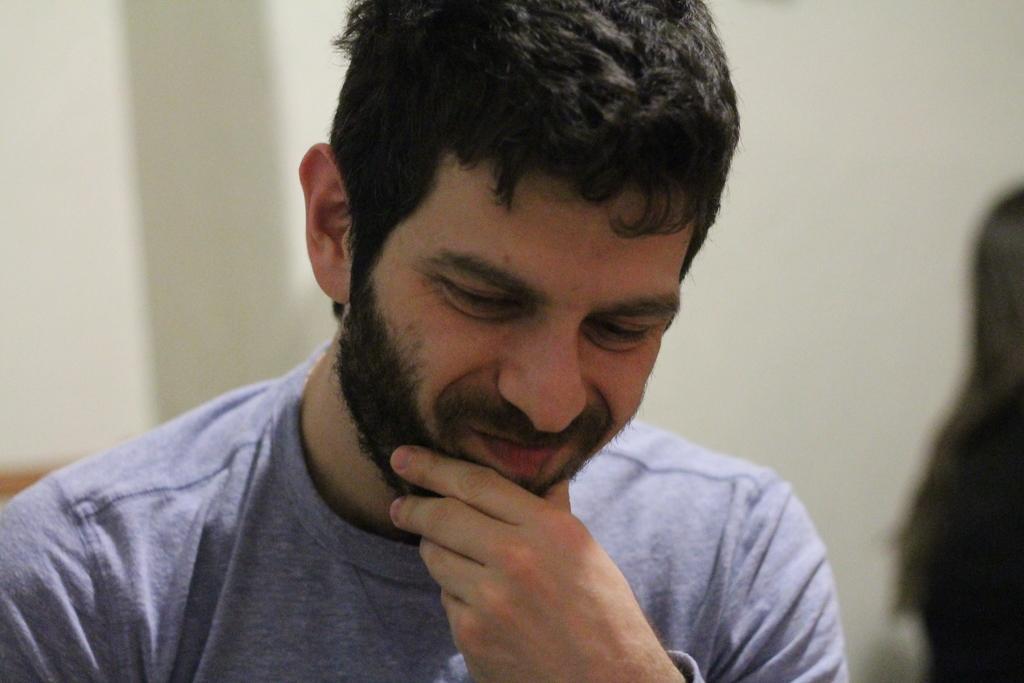How would you summarize this image in a sentence or two? In this picture, we see a man in the grey T-shirt is smiling. He might be sitting on the chair. On the right side, it is black in color. In the background, we see a white wall. This picture is blurred in the background. 